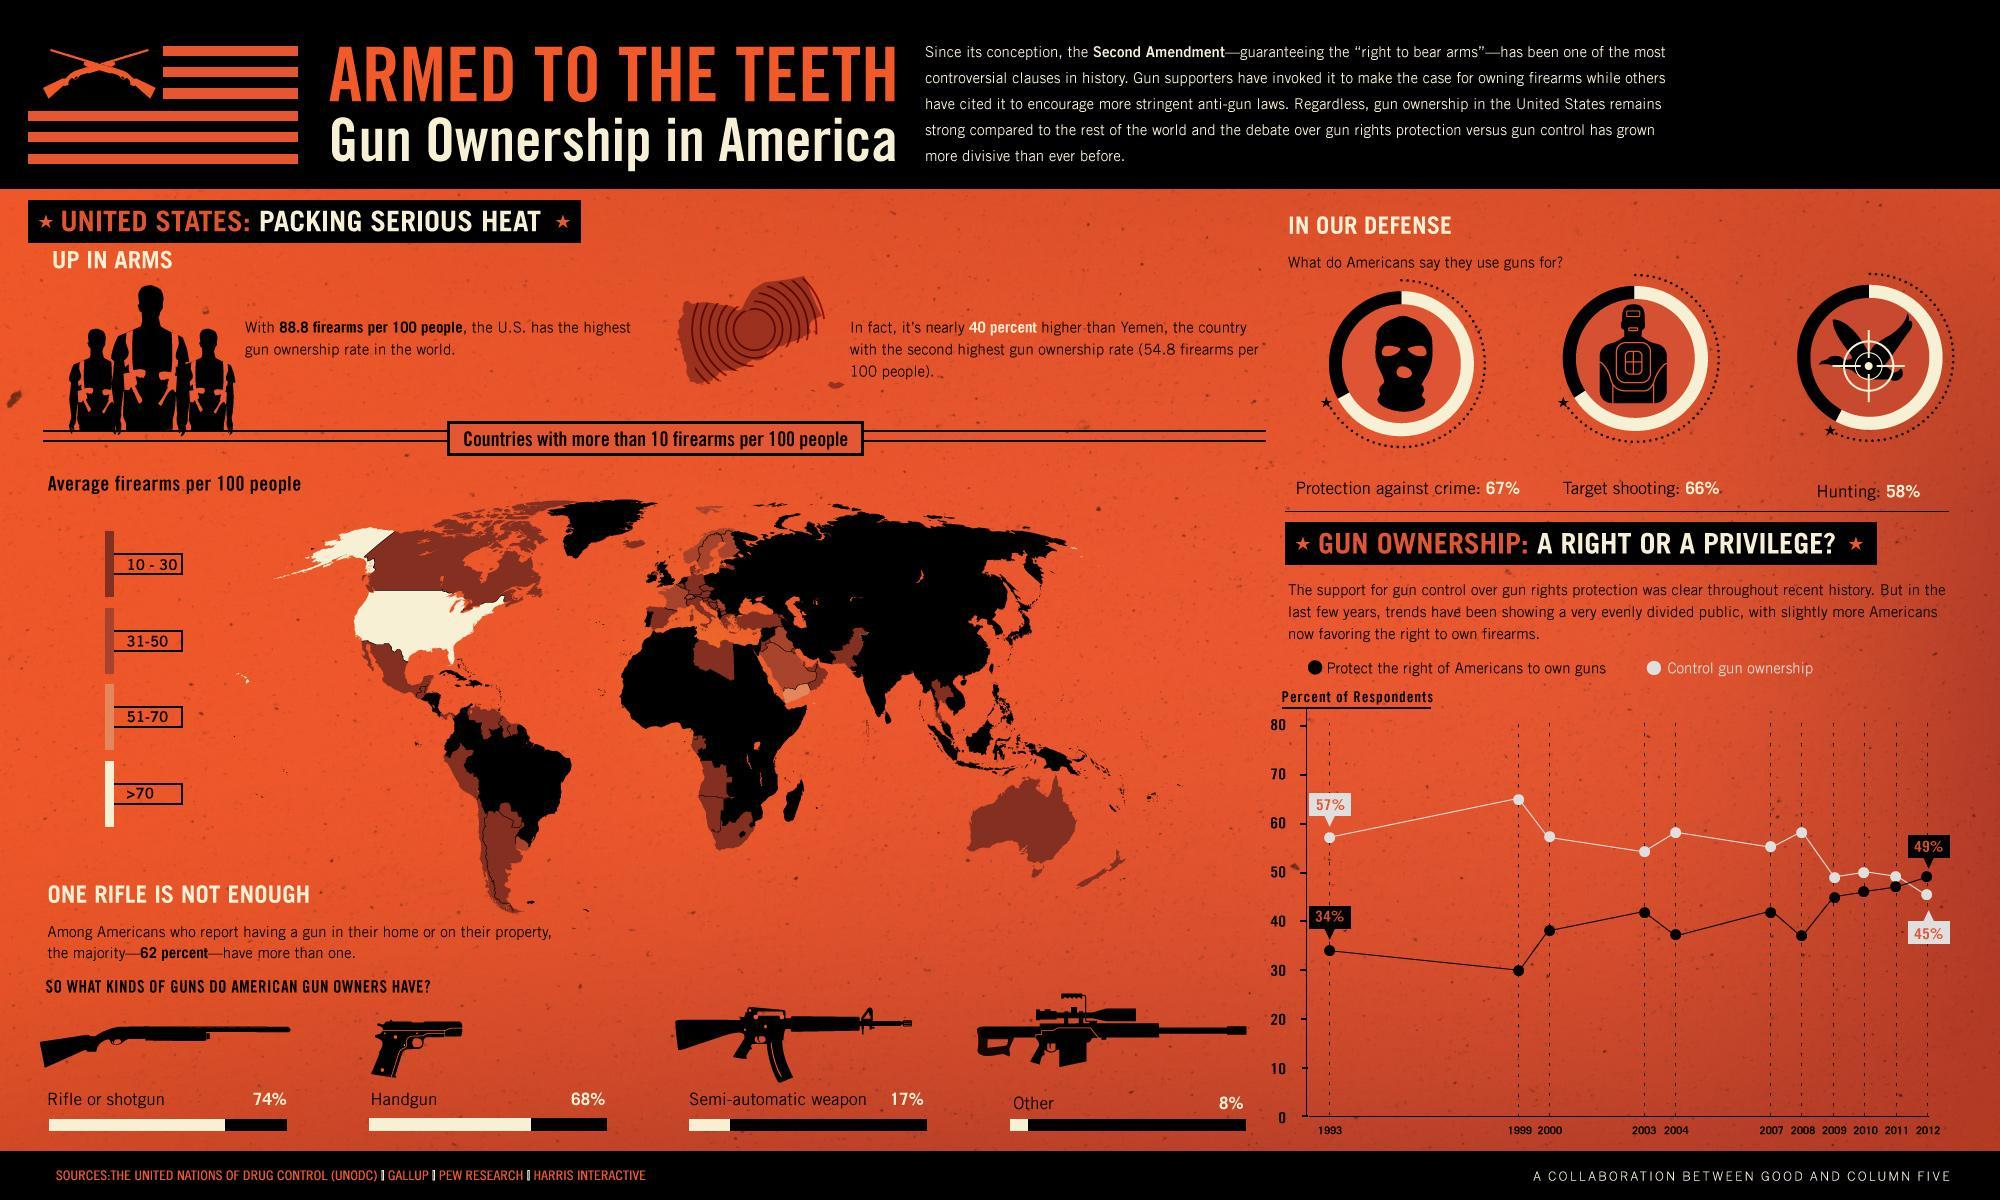What percentage of Americans use guns for hunting?
Answer the question with a short phrase. 58% What is the gun ownership rate in the U.S? 88.8 firearms per 100 people What is the percent of respondents to control gun ownership in 2012? 45% Which country has the highest gun ownership rate in the worlld? U.S. What percent of American gun owners use handguns? 68% What kind of gun do the American gun owners use the most? Rifle or shotgun What percent of Americans do not use guns for target shooting? 34% Which country's gunownership rate is 40% less than U.S? Yemen 